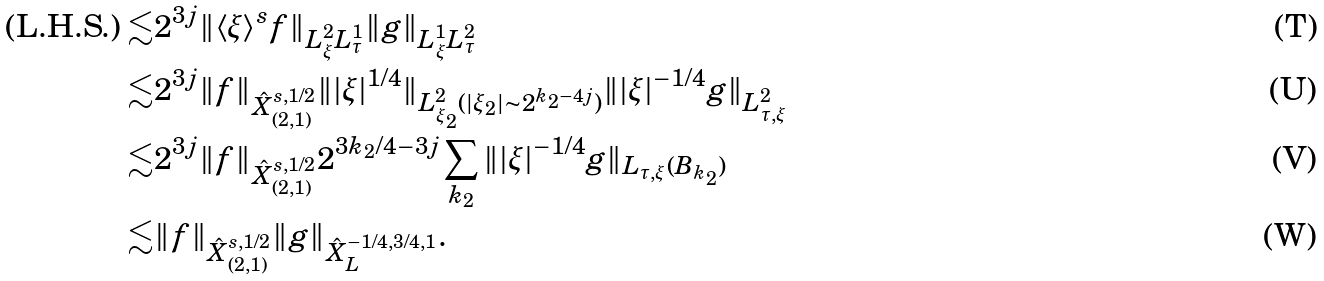<formula> <loc_0><loc_0><loc_500><loc_500>\text {(L.H.S.)} \lesssim & 2 ^ { 3 j } \| \langle \xi \rangle ^ { s } f \| _ { L _ { \xi } ^ { 2 } L _ { \tau } ^ { 1 } } \| g \| _ { L _ { \xi } ^ { 1 } L _ { \tau } ^ { 2 } } \\ \lesssim & 2 ^ { 3 j } \| f \| _ { \hat { X } _ { ( 2 , 1 ) } ^ { s , 1 / 2 } } \| | \xi | ^ { 1 / 4 } \| _ { L _ { \xi _ { 2 } } ^ { 2 } ( | \xi _ { 2 } | \sim 2 ^ { k _ { 2 } - 4 j } ) } \| | \xi | ^ { - 1 / 4 } g \| _ { L _ { \tau , \xi } ^ { 2 } } \\ \lesssim & 2 ^ { 3 j } \| f \| _ { \hat { X } _ { ( 2 , 1 ) } ^ { s , 1 / 2 } } 2 ^ { 3 k _ { 2 } / 4 - 3 j } \sum _ { k _ { 2 } } \| | \xi | ^ { - 1 / 4 } g \| _ { L _ { \tau , \xi } ( B _ { k _ { 2 } } ) } \\ \lesssim & \| f \| _ { \hat { X } _ { ( 2 , 1 ) } ^ { s , 1 / 2 } } \| g \| _ { \hat { X } _ { L } ^ { - 1 / 4 , 3 / 4 , 1 } } .</formula> 